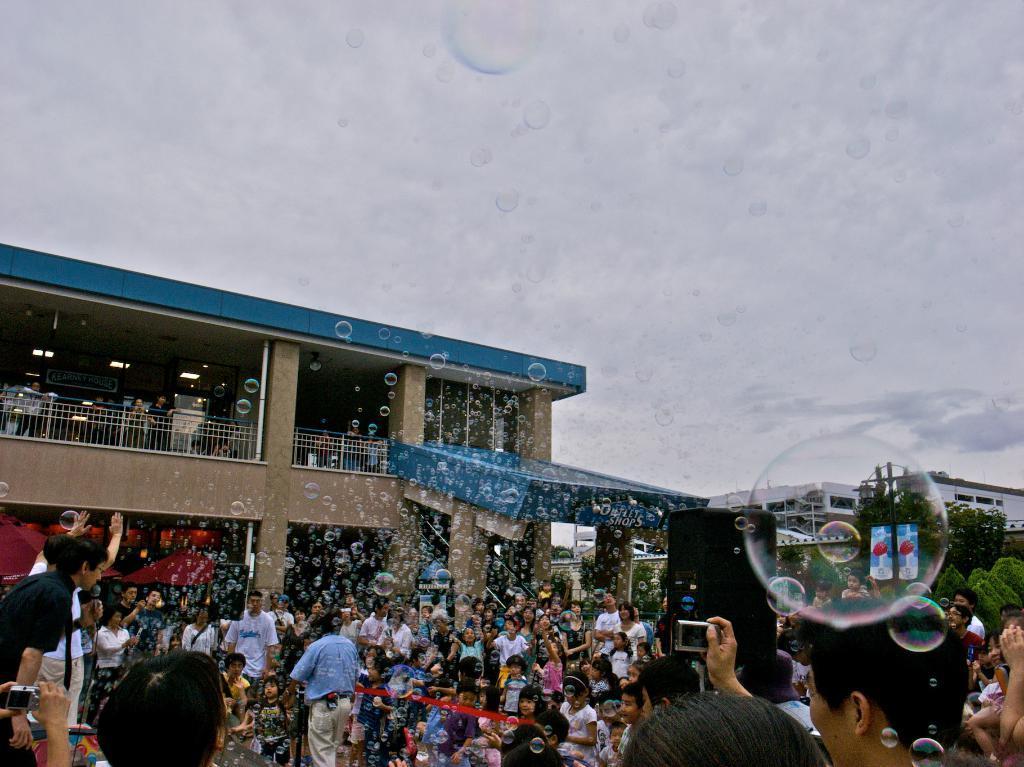Please provide a concise description of this image. At the bottom of the picture there are people, bubbles, trees and buildings. In the middle of the picture there are bubbles. Sky is cloudy. 